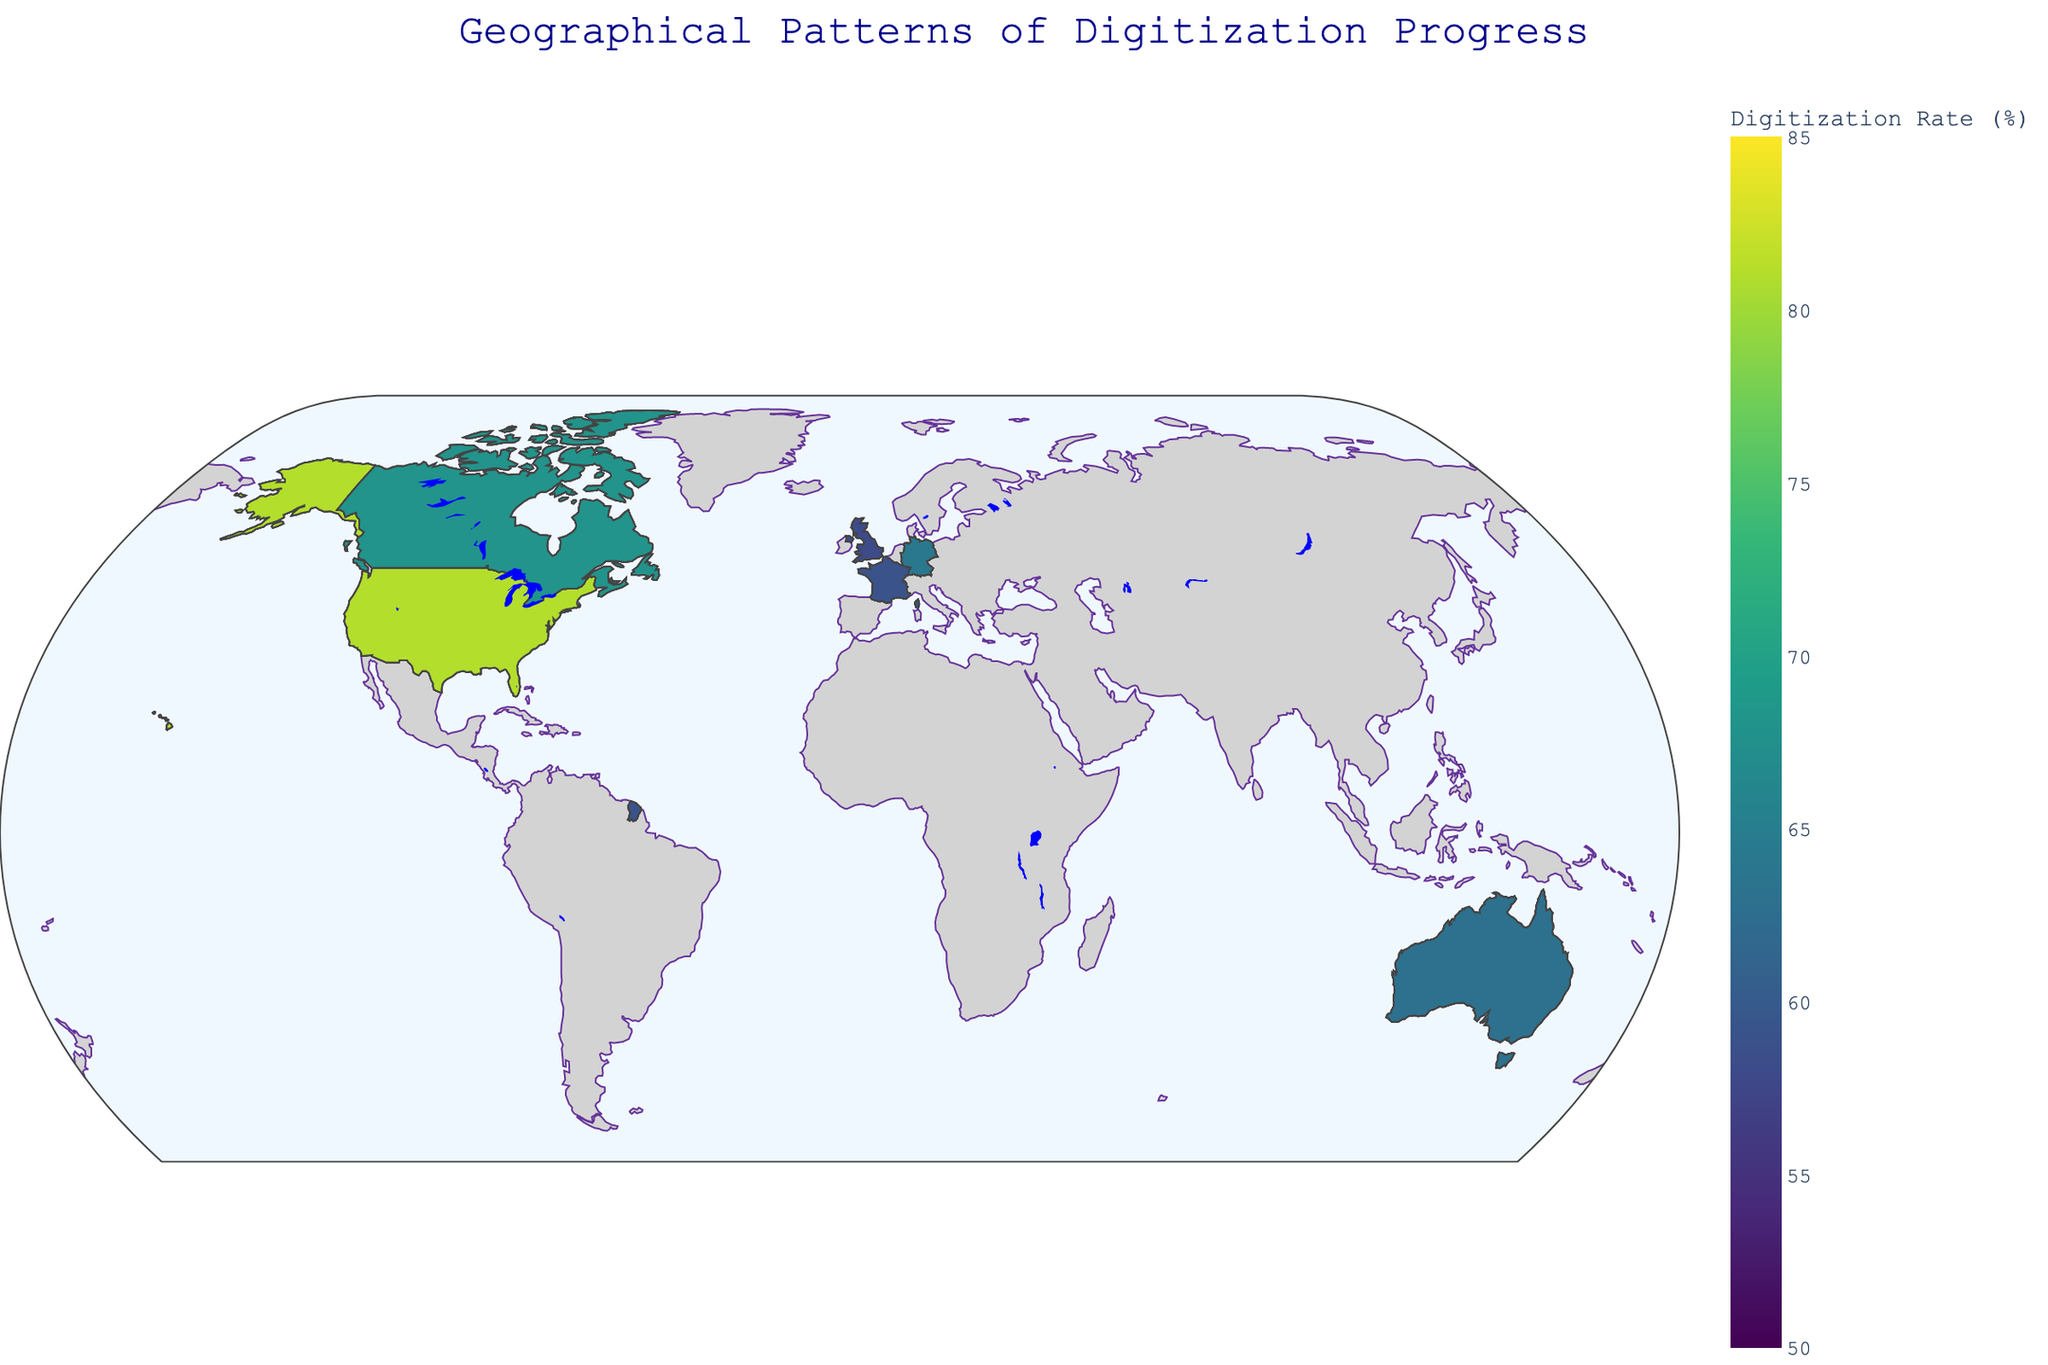What's the title of the figure? The title of the figure is usually found at the top and it summarizes the content of the plot. In this case, it reads "Geographical Patterns of Digitization Progress".
Answer: Geographical Patterns of Digitization Progress Which country region has the highest digitization rate? To find the highest digitization rate, look for the region with the darkest color on the choropleth map. By comparing values, the region in the United States (West) shows the highest digitization rate at 81%.
Answer: United States - West What is the color scale used to represent digitization rates? The color scale used in the figure is the Viridis scale, indicated by shades from yellow through green to blue. This scale shows lower values in yellow and higher values in blue.
Answer: Viridis What’s the average digitization rate for regions in Australia? Calculate the average by summing the digitization rates of all Australian regions (71, 74, 67, 63) and dividing by the number of regions, which is 4. (71 + 74 + 67 + 63) / 4 equals 68.75
Answer: 68.75 How does the digitization rate of Île-de-France compare to Nouvelle-Aquitaine? Compare the digitization rates shown on the map. Île-de-France has a rate of 77%, while Nouvelle-Aquitaine has a rate of 62%. Therefore, Île-de-France's rate is higher.
Answer: Île-de-France is higher Which region in the United Kingdom has the lowest digitization rate? Look at the rates for regions within the United Kingdom: England (73), Scotland (69), Wales (61), and Northern Ireland (58). Northern Ireland has the lowest digitization rate.
Answer: Northern Ireland Between Germany and Canada, which country overall shows higher digitization rates in its regions? Compare the regional rates in Germany (70, 75, 72, 64) and Canada (76, 72, 79, 68). Germany's average rate is (70+75+72+64)/4 = 70.25, and Canada's is (76+72+79+68)/4 = 73.75. Canada has the higher overall rate.
Answer: Canada What’s the range of digitization rates represented in the figure? The range is the difference between the highest and the lowest digitization rates shown. The maximum rate is 81 (United States - West) and the minimum rate is 52 (United States - South). The range is 81 - 52 = 29.
Answer: 29 What region in France shows the highest digitization rate? Among the regions in France—Île-de-France (77), Auvergne-Rhône-Alpes (69), Nouvelle-Aquitaine (62), and Occitanie (59)—Île-de-France has the highest rate.
Answer: Île-de-France 